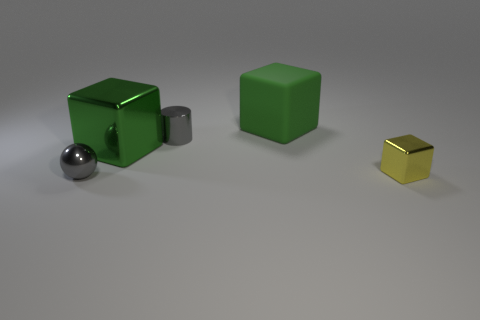Is there a metallic thing of the same color as the cylinder?
Your answer should be very brief. Yes. There is a large thing that is the same color as the matte cube; what shape is it?
Keep it short and to the point. Cube. There is a green metallic object that is in front of the large matte block; how big is it?
Your answer should be very brief. Large. What shape is the other large thing that is made of the same material as the yellow object?
Offer a terse response. Cube. Do the small gray cylinder and the large green block that is on the right side of the large green metal thing have the same material?
Make the answer very short. No. There is a object on the left side of the green shiny block; is it the same shape as the small yellow metal thing?
Your answer should be compact. No. What is the material of the other green object that is the same shape as the big shiny thing?
Provide a short and direct response. Rubber. There is a big metallic object; is its shape the same as the tiny gray object left of the small metallic cylinder?
Ensure brevity in your answer.  No. What color is the block that is to the right of the tiny cylinder and in front of the large rubber cube?
Offer a terse response. Yellow. Is there a big gray matte cube?
Ensure brevity in your answer.  No. 